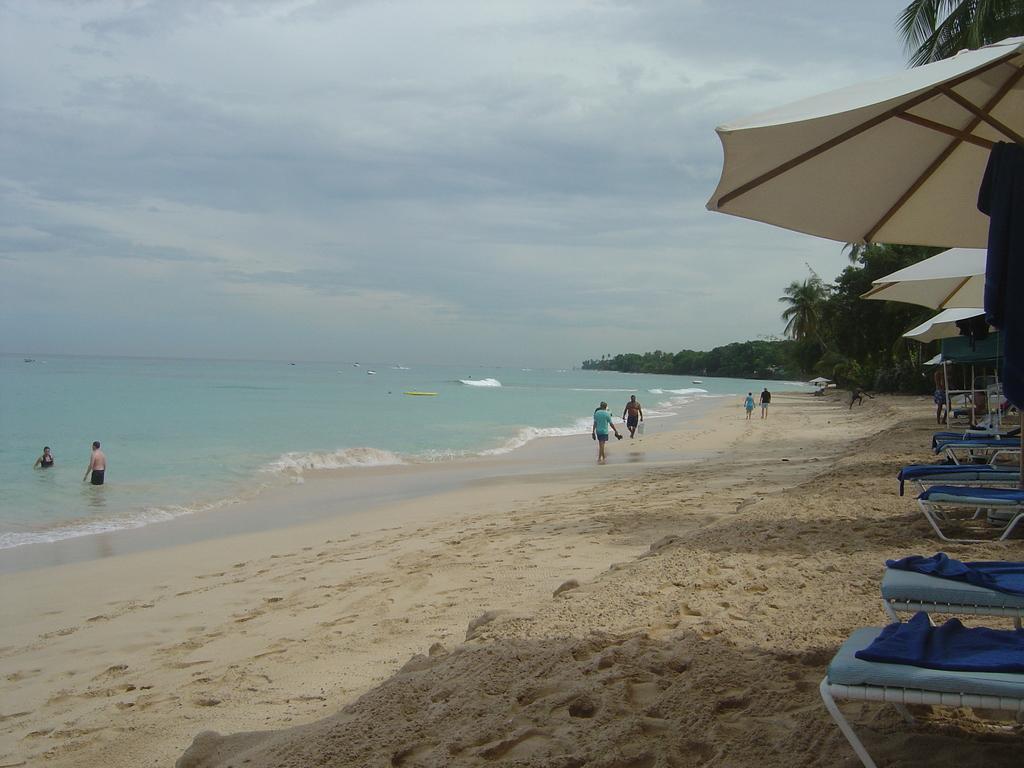Can you describe this image briefly? In the picture we can see the sand surface near the ocean and on the sand surface, we can see some people are walking and two people are standing in the water and on the sand surface, we can see some benches with blue clothes and umbrellas and in the background we can see the trees and the sky. 